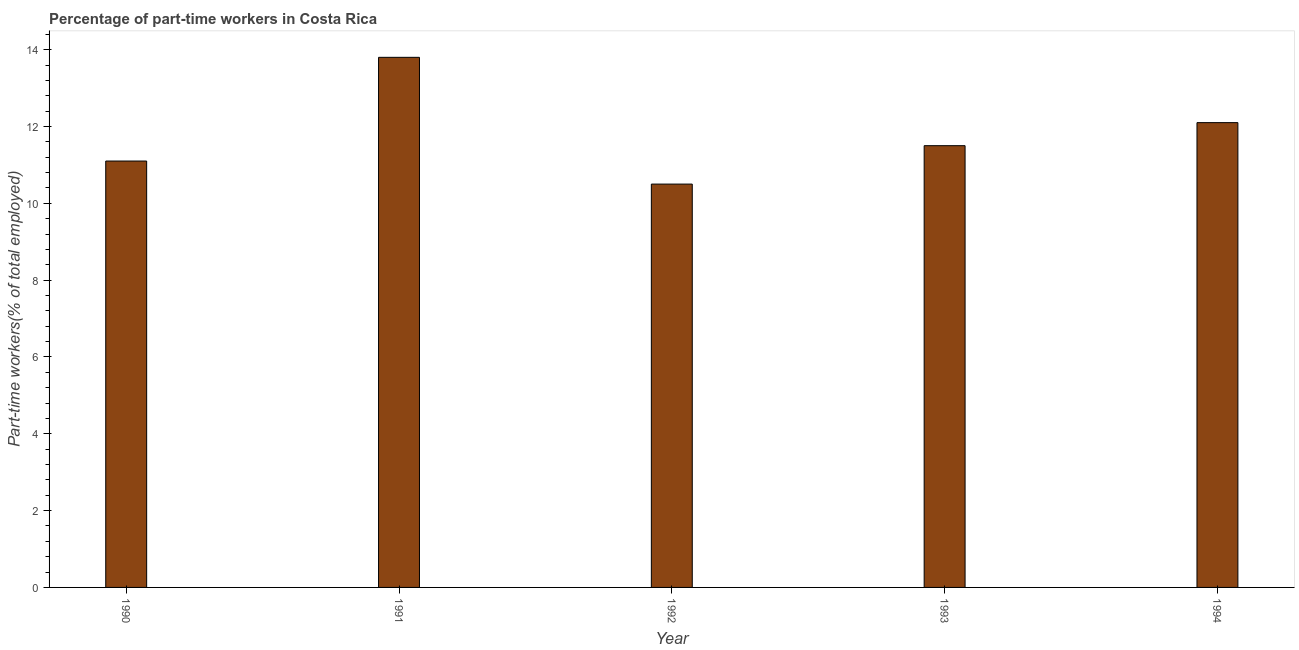Does the graph contain any zero values?
Provide a succinct answer. No. What is the title of the graph?
Your response must be concise. Percentage of part-time workers in Costa Rica. What is the label or title of the Y-axis?
Your answer should be very brief. Part-time workers(% of total employed). What is the percentage of part-time workers in 1990?
Keep it short and to the point. 11.1. Across all years, what is the maximum percentage of part-time workers?
Provide a succinct answer. 13.8. Across all years, what is the minimum percentage of part-time workers?
Ensure brevity in your answer.  10.5. In which year was the percentage of part-time workers minimum?
Offer a terse response. 1992. What is the sum of the percentage of part-time workers?
Provide a short and direct response. 59. What is the difference between the percentage of part-time workers in 1991 and 1993?
Offer a very short reply. 2.3. What is the ratio of the percentage of part-time workers in 1992 to that in 1993?
Keep it short and to the point. 0.91. Is the percentage of part-time workers in 1992 less than that in 1993?
Your answer should be very brief. Yes. Is the difference between the percentage of part-time workers in 1990 and 1994 greater than the difference between any two years?
Provide a succinct answer. No. Is the sum of the percentage of part-time workers in 1992 and 1994 greater than the maximum percentage of part-time workers across all years?
Make the answer very short. Yes. In how many years, is the percentage of part-time workers greater than the average percentage of part-time workers taken over all years?
Your answer should be compact. 2. Are the values on the major ticks of Y-axis written in scientific E-notation?
Your response must be concise. No. What is the Part-time workers(% of total employed) in 1990?
Your response must be concise. 11.1. What is the Part-time workers(% of total employed) of 1991?
Your answer should be compact. 13.8. What is the Part-time workers(% of total employed) of 1993?
Ensure brevity in your answer.  11.5. What is the Part-time workers(% of total employed) in 1994?
Offer a very short reply. 12.1. What is the difference between the Part-time workers(% of total employed) in 1991 and 1992?
Make the answer very short. 3.3. What is the difference between the Part-time workers(% of total employed) in 1991 and 1993?
Ensure brevity in your answer.  2.3. What is the difference between the Part-time workers(% of total employed) in 1991 and 1994?
Provide a succinct answer. 1.7. What is the difference between the Part-time workers(% of total employed) in 1992 and 1993?
Ensure brevity in your answer.  -1. What is the difference between the Part-time workers(% of total employed) in 1993 and 1994?
Provide a succinct answer. -0.6. What is the ratio of the Part-time workers(% of total employed) in 1990 to that in 1991?
Keep it short and to the point. 0.8. What is the ratio of the Part-time workers(% of total employed) in 1990 to that in 1992?
Offer a very short reply. 1.06. What is the ratio of the Part-time workers(% of total employed) in 1990 to that in 1994?
Offer a very short reply. 0.92. What is the ratio of the Part-time workers(% of total employed) in 1991 to that in 1992?
Make the answer very short. 1.31. What is the ratio of the Part-time workers(% of total employed) in 1991 to that in 1994?
Your response must be concise. 1.14. What is the ratio of the Part-time workers(% of total employed) in 1992 to that in 1994?
Your response must be concise. 0.87. What is the ratio of the Part-time workers(% of total employed) in 1993 to that in 1994?
Your answer should be compact. 0.95. 